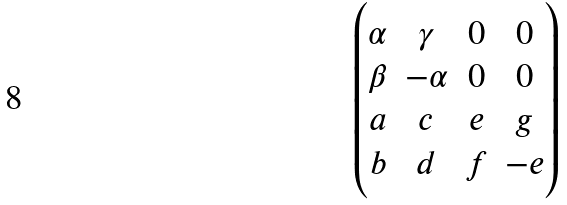<formula> <loc_0><loc_0><loc_500><loc_500>\begin{pmatrix} \alpha & \gamma & 0 & 0 \\ \beta & - \alpha & 0 & 0 \\ a & c & e & g \\ b & d & f & - e \end{pmatrix}</formula> 